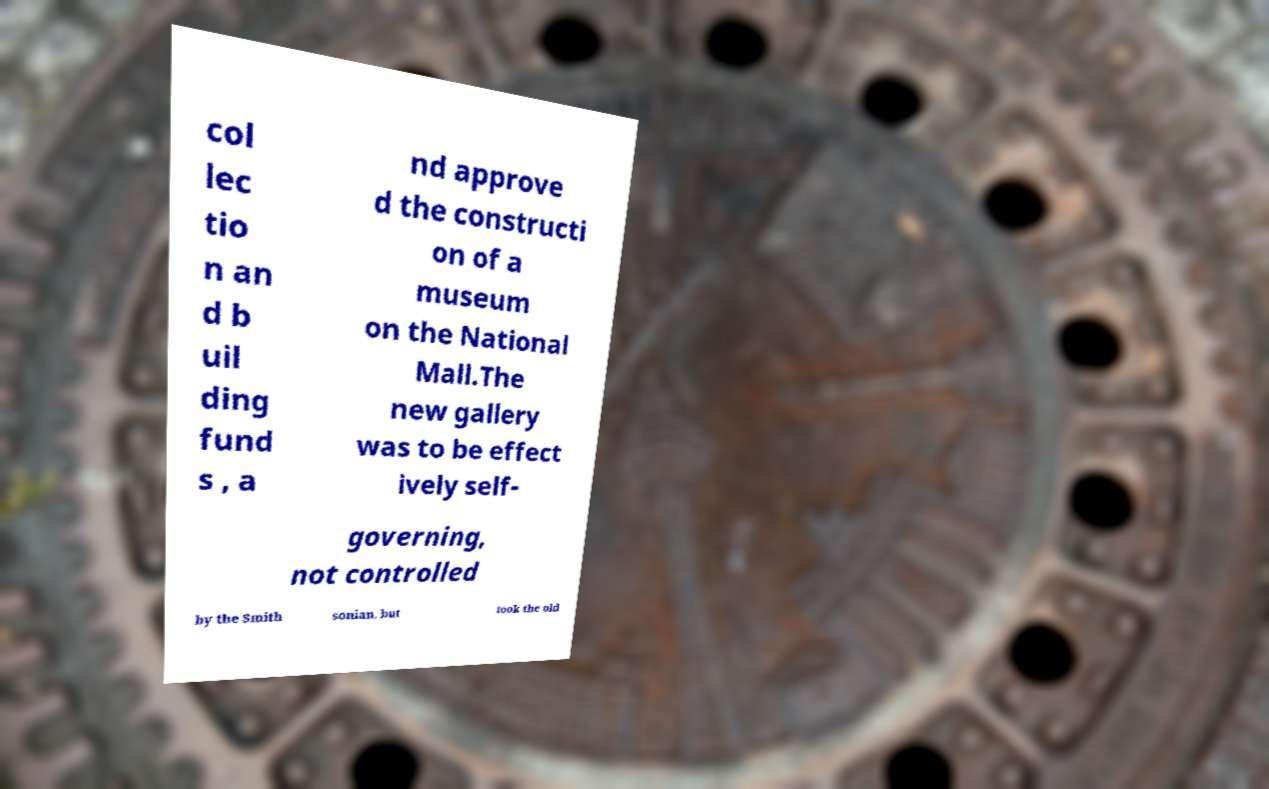Please read and relay the text visible in this image. What does it say? col lec tio n an d b uil ding fund s , a nd approve d the constructi on of a museum on the National Mall.The new gallery was to be effect ively self- governing, not controlled by the Smith sonian, but took the old 